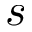<formula> <loc_0><loc_0><loc_500><loc_500>s</formula> 